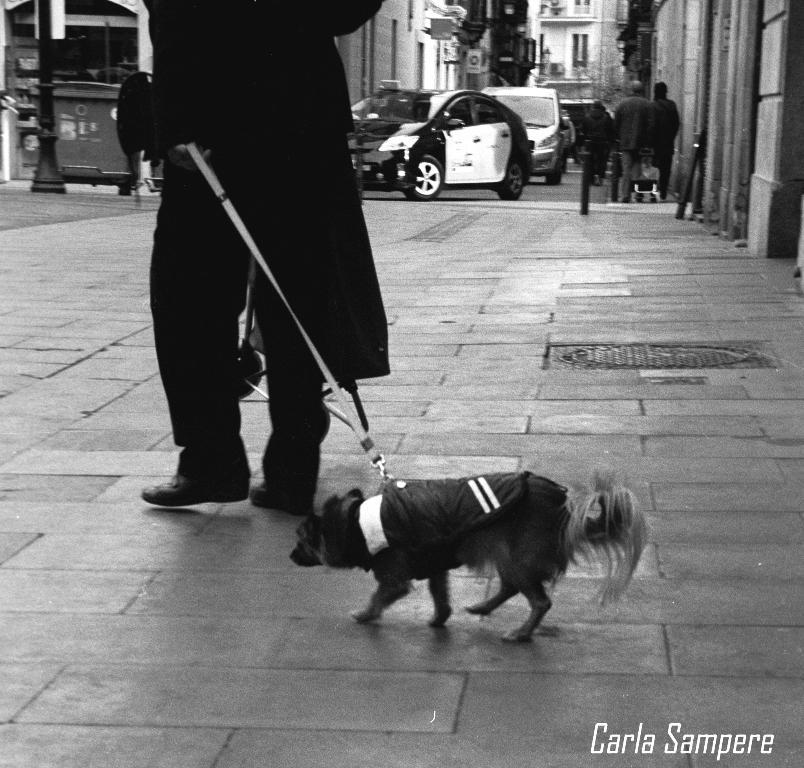Who is present in the image? There is a man in the image. What is the man doing in the image? The man is walking in the image. Is there any other living creature present in the image? Yes, there is a dog in the image. What is the dog doing in the image? The dog is walking alongside the man in the image. What type of ticket does the man have in his hand in the image? There is no ticket present in the image; the man is simply walking alongside the dog. 